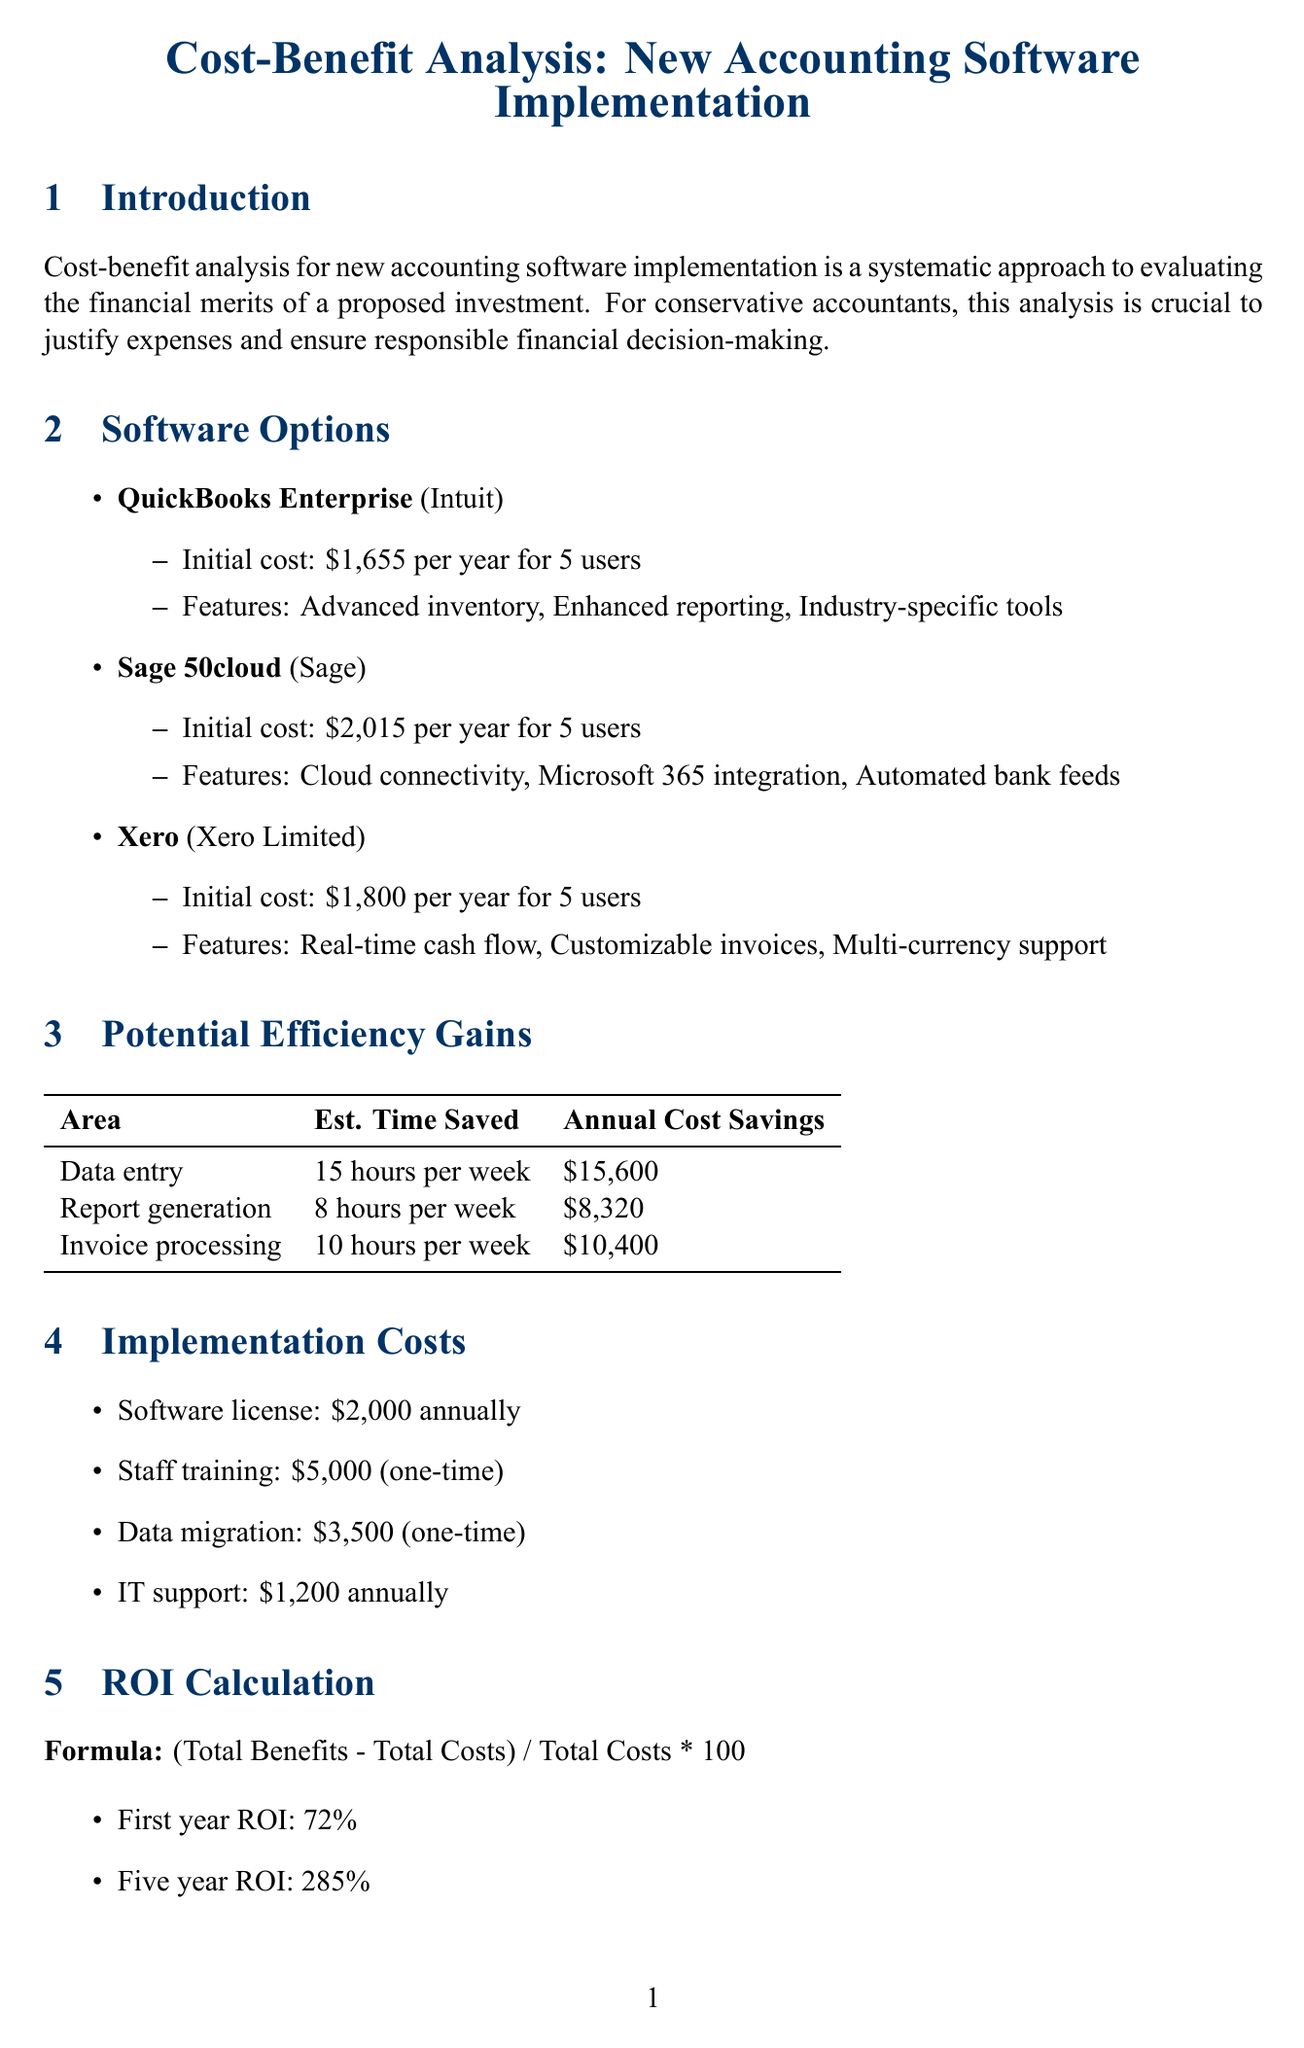What is the initial cost of QuickBooks Enterprise? The initial cost for QuickBooks Enterprise is mentioned specifically in the software options section.
Answer: $1,655 per year for 5 users What is the first year ROI percentage? The ROI calculation section provides this specific percentage for the first year.
Answer: 72% How many hours per week are estimated to be saved in report generation? This information is retrieved from the potential efficiency gains section under the estimated time saved for report generation.
Answer: 8 hours per week What is the one-time cost for staff training? The implementation costs section lists this specific one-time cost for staff training.
Answer: $5,000 Which software solution achieved a 95% ROI over three years? This information is found in the case studies section that details the performance of various software.
Answer: QuickBooks Enterprise What are the key benefits achieved by Midwest Manufacturing Co.? The key benefits are listed in the case study for Midwest Manufacturing Co.
Answer: Streamlined inventory management, Faster month-end closing, Better financial forecasting What risk factor involves data security breaches? This information is specified in the risk factors and mitigation section, highlighting the relevant risk.
Answer: Data security breaches What is the total annual cost for IT support? The implementation costs section clearly states the annual cost for IT support.
Answer: $1,200 